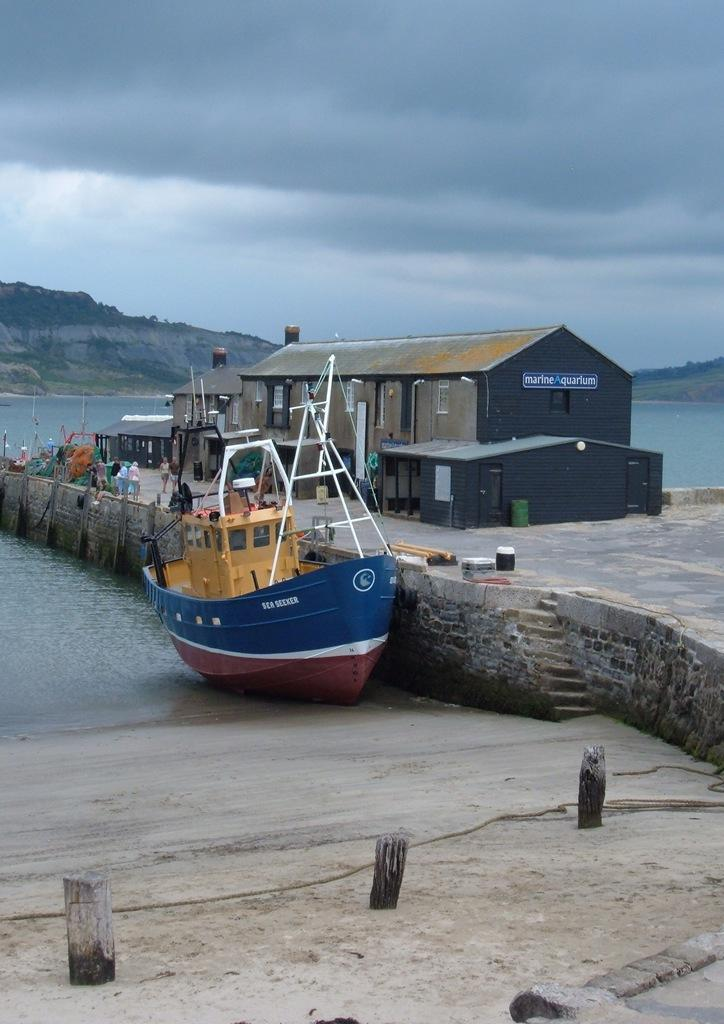What is the main subject of the image? The main subject of the image is a boat. What can be seen in the background of the image? There is water, a house, hills, and the sky visible in the image. What is the condition of the sky in the image? The sky is visible in the image, and clouds are present. Are there any people in the image? Yes, there are people present in the image. Can you tell me how many veins are visible on the boat in the image? There are no veins visible on the boat in the image, as veins are not a characteristic of boats. Are there any bats flying around the boat in the image? There are no bats visible in the image. 